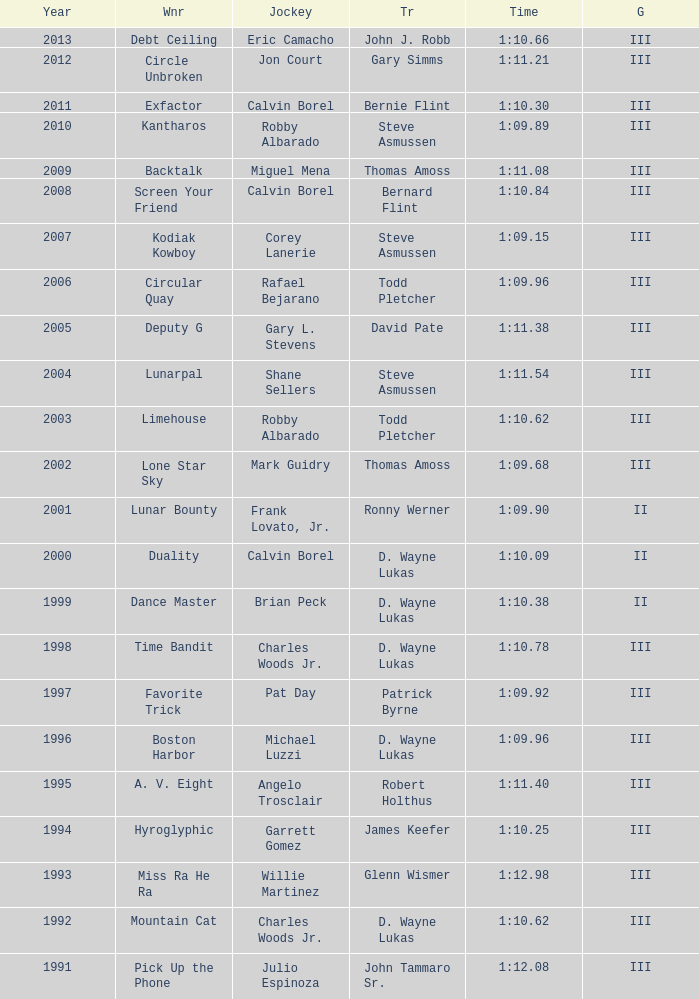Which trainer had a time of 1:10.09 with a year less than 2009? D. Wayne Lukas. 